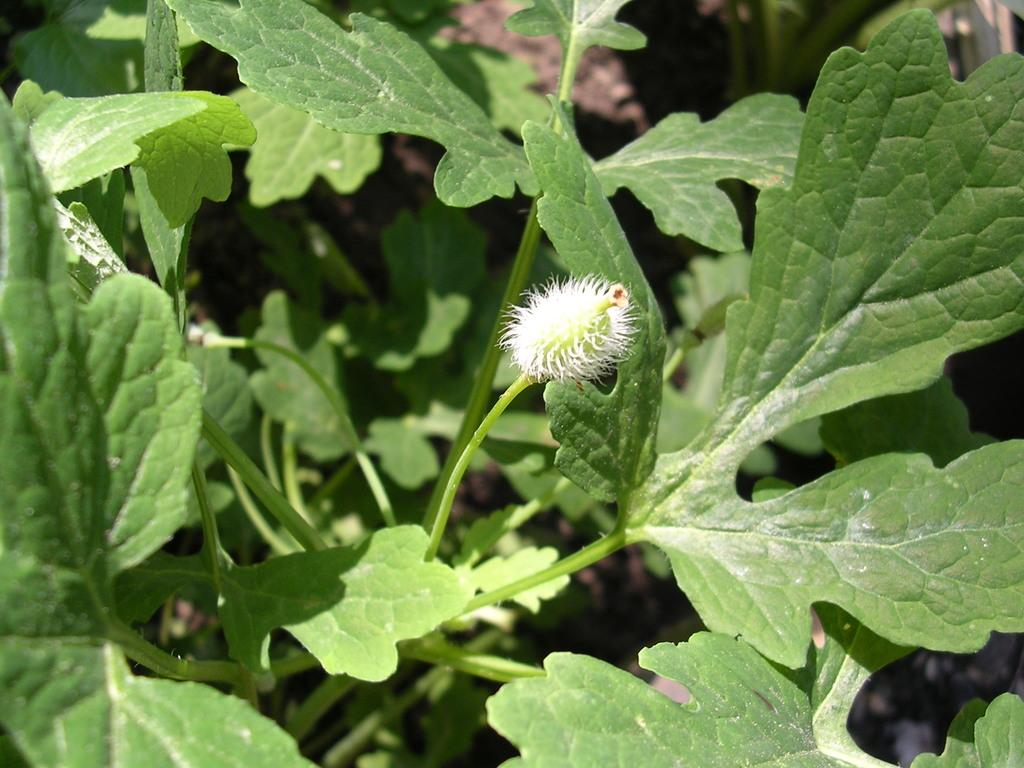What type of vegetation is present in the image? There are green leaves in the image. What is the color and location of the main object in the image? There is a white-colored object in the center of the image. What type of protest is taking place in the image? There is no protest present in the image; it only features green leaves and a white-colored object. What role does the father play in the image? There is no father present in the image, as it only contains green leaves and a white-colored object. 